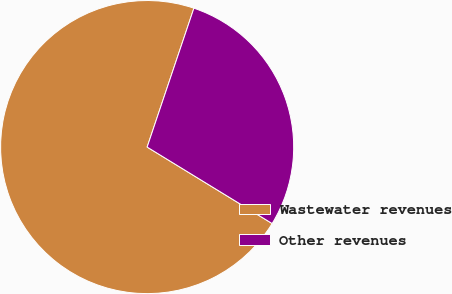Convert chart to OTSL. <chart><loc_0><loc_0><loc_500><loc_500><pie_chart><fcel>Wastewater revenues<fcel>Other revenues<nl><fcel>71.43%<fcel>28.57%<nl></chart> 